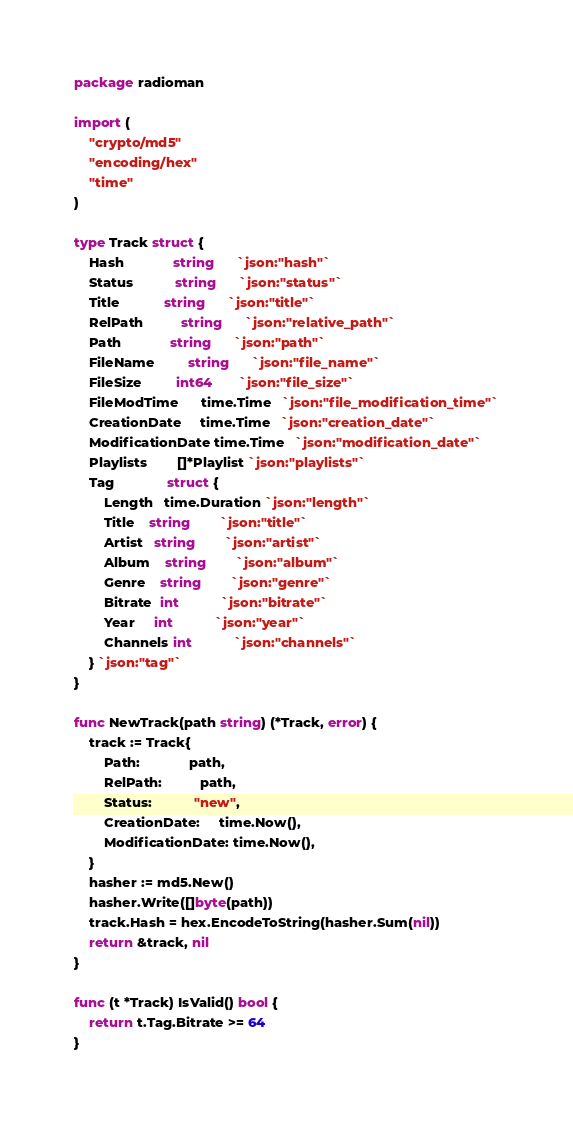<code> <loc_0><loc_0><loc_500><loc_500><_Go_>package radioman

import (
	"crypto/md5"
	"encoding/hex"
	"time"
)

type Track struct {
	Hash             string      `json:"hash"`
	Status           string      `json:"status"`
	Title            string      `json:"title"`
	RelPath          string      `json:"relative_path"`
	Path             string      `json:"path"`
	FileName         string      `json:"file_name"`
	FileSize         int64       `json:"file_size"`
	FileModTime      time.Time   `json:"file_modification_time"`
	CreationDate     time.Time   `json:"creation_date"`
	ModificationDate time.Time   `json:"modification_date"`
	Playlists        []*Playlist `json:"playlists"`
	Tag              struct {
		Length   time.Duration `json:"length"`
		Title    string        `json:"title"`
		Artist   string        `json:"artist"`
		Album    string        `json:"album"`
		Genre    string        `json:"genre"`
		Bitrate  int           `json:"bitrate"`
		Year     int           `json:"year"`
		Channels int           `json:"channels"`
	} `json:"tag"`
}

func NewTrack(path string) (*Track, error) {
	track := Track{
		Path:             path,
		RelPath:          path,
		Status:           "new",
		CreationDate:     time.Now(),
		ModificationDate: time.Now(),
	}
	hasher := md5.New()
	hasher.Write([]byte(path))
	track.Hash = hex.EncodeToString(hasher.Sum(nil))
	return &track, nil
}

func (t *Track) IsValid() bool {
	return t.Tag.Bitrate >= 64
}
</code> 